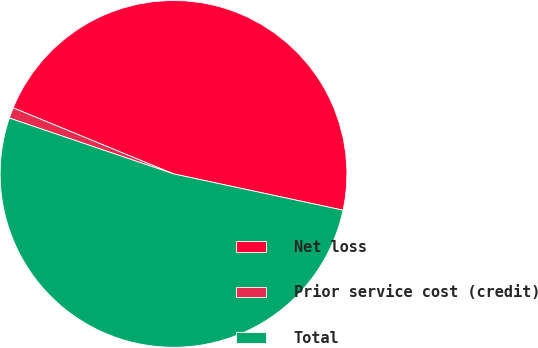Convert chart to OTSL. <chart><loc_0><loc_0><loc_500><loc_500><pie_chart><fcel>Net loss<fcel>Prior service cost (credit)<fcel>Total<nl><fcel>47.14%<fcel>1.0%<fcel>51.86%<nl></chart> 